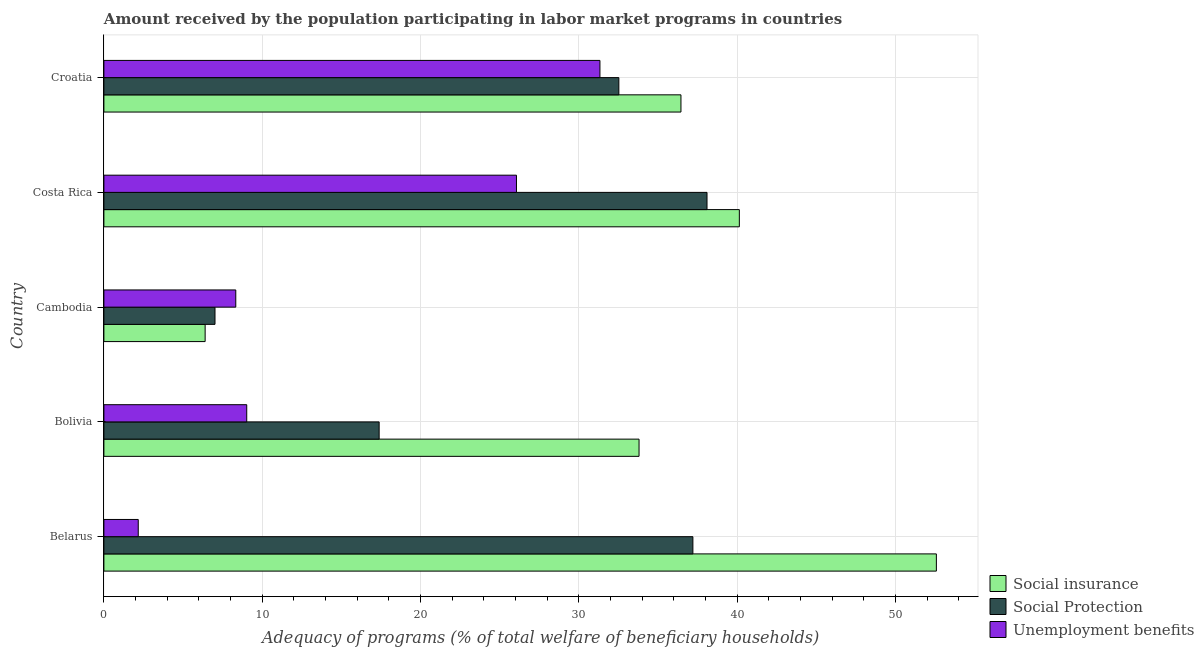How many different coloured bars are there?
Your answer should be very brief. 3. Are the number of bars per tick equal to the number of legend labels?
Offer a very short reply. Yes. What is the label of the 1st group of bars from the top?
Keep it short and to the point. Croatia. What is the amount received by the population participating in social insurance programs in Belarus?
Offer a very short reply. 52.58. Across all countries, what is the maximum amount received by the population participating in social insurance programs?
Your response must be concise. 52.58. Across all countries, what is the minimum amount received by the population participating in social insurance programs?
Your response must be concise. 6.39. In which country was the amount received by the population participating in unemployment benefits programs maximum?
Offer a very short reply. Croatia. In which country was the amount received by the population participating in social insurance programs minimum?
Your answer should be very brief. Cambodia. What is the total amount received by the population participating in social protection programs in the graph?
Offer a very short reply. 132.22. What is the difference between the amount received by the population participating in social protection programs in Belarus and that in Costa Rica?
Offer a very short reply. -0.89. What is the difference between the amount received by the population participating in social insurance programs in Costa Rica and the amount received by the population participating in unemployment benefits programs in Belarus?
Keep it short and to the point. 37.96. What is the average amount received by the population participating in social protection programs per country?
Your answer should be compact. 26.44. What is the difference between the amount received by the population participating in unemployment benefits programs and amount received by the population participating in social insurance programs in Bolivia?
Offer a terse response. -24.78. In how many countries, is the amount received by the population participating in social protection programs greater than 16 %?
Your answer should be compact. 4. What is the ratio of the amount received by the population participating in social protection programs in Belarus to that in Bolivia?
Provide a short and direct response. 2.14. Is the difference between the amount received by the population participating in unemployment benefits programs in Belarus and Costa Rica greater than the difference between the amount received by the population participating in social protection programs in Belarus and Costa Rica?
Your answer should be compact. No. What is the difference between the highest and the second highest amount received by the population participating in unemployment benefits programs?
Offer a very short reply. 5.27. What is the difference between the highest and the lowest amount received by the population participating in social insurance programs?
Give a very brief answer. 46.18. In how many countries, is the amount received by the population participating in social insurance programs greater than the average amount received by the population participating in social insurance programs taken over all countries?
Your answer should be very brief. 3. Is the sum of the amount received by the population participating in social insurance programs in Bolivia and Cambodia greater than the maximum amount received by the population participating in unemployment benefits programs across all countries?
Keep it short and to the point. Yes. What does the 1st bar from the top in Bolivia represents?
Offer a very short reply. Unemployment benefits. What does the 2nd bar from the bottom in Belarus represents?
Offer a terse response. Social Protection. Is it the case that in every country, the sum of the amount received by the population participating in social insurance programs and amount received by the population participating in social protection programs is greater than the amount received by the population participating in unemployment benefits programs?
Offer a very short reply. Yes. How many bars are there?
Give a very brief answer. 15. Are all the bars in the graph horizontal?
Make the answer very short. Yes. How many countries are there in the graph?
Give a very brief answer. 5. What is the difference between two consecutive major ticks on the X-axis?
Your answer should be very brief. 10. Does the graph contain any zero values?
Provide a short and direct response. No. How many legend labels are there?
Provide a succinct answer. 3. How are the legend labels stacked?
Offer a terse response. Vertical. What is the title of the graph?
Your answer should be very brief. Amount received by the population participating in labor market programs in countries. Does "Travel services" appear as one of the legend labels in the graph?
Give a very brief answer. No. What is the label or title of the X-axis?
Your answer should be compact. Adequacy of programs (% of total welfare of beneficiary households). What is the Adequacy of programs (% of total welfare of beneficiary households) in Social insurance in Belarus?
Offer a terse response. 52.58. What is the Adequacy of programs (% of total welfare of beneficiary households) in Social Protection in Belarus?
Provide a short and direct response. 37.2. What is the Adequacy of programs (% of total welfare of beneficiary households) in Unemployment benefits in Belarus?
Give a very brief answer. 2.17. What is the Adequacy of programs (% of total welfare of beneficiary households) of Social insurance in Bolivia?
Offer a very short reply. 33.8. What is the Adequacy of programs (% of total welfare of beneficiary households) in Social Protection in Bolivia?
Offer a terse response. 17.39. What is the Adequacy of programs (% of total welfare of beneficiary households) in Unemployment benefits in Bolivia?
Your response must be concise. 9.02. What is the Adequacy of programs (% of total welfare of beneficiary households) of Social insurance in Cambodia?
Provide a short and direct response. 6.39. What is the Adequacy of programs (% of total welfare of beneficiary households) of Social Protection in Cambodia?
Your response must be concise. 7.02. What is the Adequacy of programs (% of total welfare of beneficiary households) of Unemployment benefits in Cambodia?
Make the answer very short. 8.33. What is the Adequacy of programs (% of total welfare of beneficiary households) in Social insurance in Costa Rica?
Give a very brief answer. 40.13. What is the Adequacy of programs (% of total welfare of beneficiary households) in Social Protection in Costa Rica?
Offer a terse response. 38.09. What is the Adequacy of programs (% of total welfare of beneficiary households) in Unemployment benefits in Costa Rica?
Provide a short and direct response. 26.06. What is the Adequacy of programs (% of total welfare of beneficiary households) of Social insurance in Croatia?
Offer a terse response. 36.45. What is the Adequacy of programs (% of total welfare of beneficiary households) in Social Protection in Croatia?
Ensure brevity in your answer.  32.52. What is the Adequacy of programs (% of total welfare of beneficiary households) of Unemployment benefits in Croatia?
Your answer should be compact. 31.33. Across all countries, what is the maximum Adequacy of programs (% of total welfare of beneficiary households) in Social insurance?
Your response must be concise. 52.58. Across all countries, what is the maximum Adequacy of programs (% of total welfare of beneficiary households) in Social Protection?
Offer a terse response. 38.09. Across all countries, what is the maximum Adequacy of programs (% of total welfare of beneficiary households) in Unemployment benefits?
Keep it short and to the point. 31.33. Across all countries, what is the minimum Adequacy of programs (% of total welfare of beneficiary households) of Social insurance?
Give a very brief answer. 6.39. Across all countries, what is the minimum Adequacy of programs (% of total welfare of beneficiary households) of Social Protection?
Provide a short and direct response. 7.02. Across all countries, what is the minimum Adequacy of programs (% of total welfare of beneficiary households) of Unemployment benefits?
Offer a terse response. 2.17. What is the total Adequacy of programs (% of total welfare of beneficiary households) of Social insurance in the graph?
Provide a succinct answer. 169.36. What is the total Adequacy of programs (% of total welfare of beneficiary households) in Social Protection in the graph?
Your answer should be very brief. 132.22. What is the total Adequacy of programs (% of total welfare of beneficiary households) of Unemployment benefits in the graph?
Provide a short and direct response. 76.91. What is the difference between the Adequacy of programs (% of total welfare of beneficiary households) of Social insurance in Belarus and that in Bolivia?
Your response must be concise. 18.78. What is the difference between the Adequacy of programs (% of total welfare of beneficiary households) of Social Protection in Belarus and that in Bolivia?
Provide a succinct answer. 19.82. What is the difference between the Adequacy of programs (% of total welfare of beneficiary households) of Unemployment benefits in Belarus and that in Bolivia?
Your answer should be very brief. -6.85. What is the difference between the Adequacy of programs (% of total welfare of beneficiary households) of Social insurance in Belarus and that in Cambodia?
Provide a short and direct response. 46.18. What is the difference between the Adequacy of programs (% of total welfare of beneficiary households) of Social Protection in Belarus and that in Cambodia?
Keep it short and to the point. 30.18. What is the difference between the Adequacy of programs (% of total welfare of beneficiary households) of Unemployment benefits in Belarus and that in Cambodia?
Offer a very short reply. -6.16. What is the difference between the Adequacy of programs (% of total welfare of beneficiary households) of Social insurance in Belarus and that in Costa Rica?
Keep it short and to the point. 12.44. What is the difference between the Adequacy of programs (% of total welfare of beneficiary households) in Social Protection in Belarus and that in Costa Rica?
Offer a very short reply. -0.89. What is the difference between the Adequacy of programs (% of total welfare of beneficiary households) of Unemployment benefits in Belarus and that in Costa Rica?
Give a very brief answer. -23.89. What is the difference between the Adequacy of programs (% of total welfare of beneficiary households) in Social insurance in Belarus and that in Croatia?
Provide a short and direct response. 16.13. What is the difference between the Adequacy of programs (% of total welfare of beneficiary households) in Social Protection in Belarus and that in Croatia?
Offer a terse response. 4.68. What is the difference between the Adequacy of programs (% of total welfare of beneficiary households) in Unemployment benefits in Belarus and that in Croatia?
Your answer should be compact. -29.16. What is the difference between the Adequacy of programs (% of total welfare of beneficiary households) of Social insurance in Bolivia and that in Cambodia?
Keep it short and to the point. 27.41. What is the difference between the Adequacy of programs (% of total welfare of beneficiary households) in Social Protection in Bolivia and that in Cambodia?
Provide a succinct answer. 10.37. What is the difference between the Adequacy of programs (% of total welfare of beneficiary households) of Unemployment benefits in Bolivia and that in Cambodia?
Your answer should be compact. 0.69. What is the difference between the Adequacy of programs (% of total welfare of beneficiary households) of Social insurance in Bolivia and that in Costa Rica?
Provide a short and direct response. -6.33. What is the difference between the Adequacy of programs (% of total welfare of beneficiary households) in Social Protection in Bolivia and that in Costa Rica?
Offer a terse response. -20.71. What is the difference between the Adequacy of programs (% of total welfare of beneficiary households) of Unemployment benefits in Bolivia and that in Costa Rica?
Your answer should be very brief. -17.04. What is the difference between the Adequacy of programs (% of total welfare of beneficiary households) of Social insurance in Bolivia and that in Croatia?
Your answer should be compact. -2.65. What is the difference between the Adequacy of programs (% of total welfare of beneficiary households) of Social Protection in Bolivia and that in Croatia?
Ensure brevity in your answer.  -15.14. What is the difference between the Adequacy of programs (% of total welfare of beneficiary households) of Unemployment benefits in Bolivia and that in Croatia?
Offer a terse response. -22.31. What is the difference between the Adequacy of programs (% of total welfare of beneficiary households) of Social insurance in Cambodia and that in Costa Rica?
Offer a terse response. -33.74. What is the difference between the Adequacy of programs (% of total welfare of beneficiary households) in Social Protection in Cambodia and that in Costa Rica?
Ensure brevity in your answer.  -31.08. What is the difference between the Adequacy of programs (% of total welfare of beneficiary households) of Unemployment benefits in Cambodia and that in Costa Rica?
Give a very brief answer. -17.73. What is the difference between the Adequacy of programs (% of total welfare of beneficiary households) of Social insurance in Cambodia and that in Croatia?
Provide a succinct answer. -30.05. What is the difference between the Adequacy of programs (% of total welfare of beneficiary households) of Social Protection in Cambodia and that in Croatia?
Offer a terse response. -25.51. What is the difference between the Adequacy of programs (% of total welfare of beneficiary households) in Unemployment benefits in Cambodia and that in Croatia?
Give a very brief answer. -23. What is the difference between the Adequacy of programs (% of total welfare of beneficiary households) in Social insurance in Costa Rica and that in Croatia?
Give a very brief answer. 3.69. What is the difference between the Adequacy of programs (% of total welfare of beneficiary households) in Social Protection in Costa Rica and that in Croatia?
Your response must be concise. 5.57. What is the difference between the Adequacy of programs (% of total welfare of beneficiary households) of Unemployment benefits in Costa Rica and that in Croatia?
Make the answer very short. -5.27. What is the difference between the Adequacy of programs (% of total welfare of beneficiary households) in Social insurance in Belarus and the Adequacy of programs (% of total welfare of beneficiary households) in Social Protection in Bolivia?
Ensure brevity in your answer.  35.19. What is the difference between the Adequacy of programs (% of total welfare of beneficiary households) of Social insurance in Belarus and the Adequacy of programs (% of total welfare of beneficiary households) of Unemployment benefits in Bolivia?
Your answer should be very brief. 43.56. What is the difference between the Adequacy of programs (% of total welfare of beneficiary households) of Social Protection in Belarus and the Adequacy of programs (% of total welfare of beneficiary households) of Unemployment benefits in Bolivia?
Give a very brief answer. 28.18. What is the difference between the Adequacy of programs (% of total welfare of beneficiary households) of Social insurance in Belarus and the Adequacy of programs (% of total welfare of beneficiary households) of Social Protection in Cambodia?
Ensure brevity in your answer.  45.56. What is the difference between the Adequacy of programs (% of total welfare of beneficiary households) of Social insurance in Belarus and the Adequacy of programs (% of total welfare of beneficiary households) of Unemployment benefits in Cambodia?
Provide a short and direct response. 44.25. What is the difference between the Adequacy of programs (% of total welfare of beneficiary households) in Social Protection in Belarus and the Adequacy of programs (% of total welfare of beneficiary households) in Unemployment benefits in Cambodia?
Your response must be concise. 28.87. What is the difference between the Adequacy of programs (% of total welfare of beneficiary households) of Social insurance in Belarus and the Adequacy of programs (% of total welfare of beneficiary households) of Social Protection in Costa Rica?
Make the answer very short. 14.49. What is the difference between the Adequacy of programs (% of total welfare of beneficiary households) of Social insurance in Belarus and the Adequacy of programs (% of total welfare of beneficiary households) of Unemployment benefits in Costa Rica?
Your answer should be very brief. 26.52. What is the difference between the Adequacy of programs (% of total welfare of beneficiary households) of Social Protection in Belarus and the Adequacy of programs (% of total welfare of beneficiary households) of Unemployment benefits in Costa Rica?
Give a very brief answer. 11.14. What is the difference between the Adequacy of programs (% of total welfare of beneficiary households) in Social insurance in Belarus and the Adequacy of programs (% of total welfare of beneficiary households) in Social Protection in Croatia?
Give a very brief answer. 20.05. What is the difference between the Adequacy of programs (% of total welfare of beneficiary households) in Social insurance in Belarus and the Adequacy of programs (% of total welfare of beneficiary households) in Unemployment benefits in Croatia?
Make the answer very short. 21.25. What is the difference between the Adequacy of programs (% of total welfare of beneficiary households) of Social Protection in Belarus and the Adequacy of programs (% of total welfare of beneficiary households) of Unemployment benefits in Croatia?
Offer a very short reply. 5.87. What is the difference between the Adequacy of programs (% of total welfare of beneficiary households) in Social insurance in Bolivia and the Adequacy of programs (% of total welfare of beneficiary households) in Social Protection in Cambodia?
Your answer should be compact. 26.78. What is the difference between the Adequacy of programs (% of total welfare of beneficiary households) in Social insurance in Bolivia and the Adequacy of programs (% of total welfare of beneficiary households) in Unemployment benefits in Cambodia?
Your answer should be very brief. 25.47. What is the difference between the Adequacy of programs (% of total welfare of beneficiary households) of Social Protection in Bolivia and the Adequacy of programs (% of total welfare of beneficiary households) of Unemployment benefits in Cambodia?
Provide a succinct answer. 9.05. What is the difference between the Adequacy of programs (% of total welfare of beneficiary households) in Social insurance in Bolivia and the Adequacy of programs (% of total welfare of beneficiary households) in Social Protection in Costa Rica?
Keep it short and to the point. -4.29. What is the difference between the Adequacy of programs (% of total welfare of beneficiary households) of Social insurance in Bolivia and the Adequacy of programs (% of total welfare of beneficiary households) of Unemployment benefits in Costa Rica?
Your answer should be compact. 7.74. What is the difference between the Adequacy of programs (% of total welfare of beneficiary households) of Social Protection in Bolivia and the Adequacy of programs (% of total welfare of beneficiary households) of Unemployment benefits in Costa Rica?
Provide a short and direct response. -8.67. What is the difference between the Adequacy of programs (% of total welfare of beneficiary households) of Social insurance in Bolivia and the Adequacy of programs (% of total welfare of beneficiary households) of Social Protection in Croatia?
Provide a succinct answer. 1.28. What is the difference between the Adequacy of programs (% of total welfare of beneficiary households) in Social insurance in Bolivia and the Adequacy of programs (% of total welfare of beneficiary households) in Unemployment benefits in Croatia?
Provide a succinct answer. 2.47. What is the difference between the Adequacy of programs (% of total welfare of beneficiary households) of Social Protection in Bolivia and the Adequacy of programs (% of total welfare of beneficiary households) of Unemployment benefits in Croatia?
Your response must be concise. -13.95. What is the difference between the Adequacy of programs (% of total welfare of beneficiary households) in Social insurance in Cambodia and the Adequacy of programs (% of total welfare of beneficiary households) in Social Protection in Costa Rica?
Give a very brief answer. -31.7. What is the difference between the Adequacy of programs (% of total welfare of beneficiary households) of Social insurance in Cambodia and the Adequacy of programs (% of total welfare of beneficiary households) of Unemployment benefits in Costa Rica?
Provide a short and direct response. -19.66. What is the difference between the Adequacy of programs (% of total welfare of beneficiary households) in Social Protection in Cambodia and the Adequacy of programs (% of total welfare of beneficiary households) in Unemployment benefits in Costa Rica?
Make the answer very short. -19.04. What is the difference between the Adequacy of programs (% of total welfare of beneficiary households) of Social insurance in Cambodia and the Adequacy of programs (% of total welfare of beneficiary households) of Social Protection in Croatia?
Offer a terse response. -26.13. What is the difference between the Adequacy of programs (% of total welfare of beneficiary households) of Social insurance in Cambodia and the Adequacy of programs (% of total welfare of beneficiary households) of Unemployment benefits in Croatia?
Your answer should be very brief. -24.94. What is the difference between the Adequacy of programs (% of total welfare of beneficiary households) in Social Protection in Cambodia and the Adequacy of programs (% of total welfare of beneficiary households) in Unemployment benefits in Croatia?
Offer a very short reply. -24.31. What is the difference between the Adequacy of programs (% of total welfare of beneficiary households) of Social insurance in Costa Rica and the Adequacy of programs (% of total welfare of beneficiary households) of Social Protection in Croatia?
Your answer should be very brief. 7.61. What is the difference between the Adequacy of programs (% of total welfare of beneficiary households) of Social insurance in Costa Rica and the Adequacy of programs (% of total welfare of beneficiary households) of Unemployment benefits in Croatia?
Offer a very short reply. 8.8. What is the difference between the Adequacy of programs (% of total welfare of beneficiary households) in Social Protection in Costa Rica and the Adequacy of programs (% of total welfare of beneficiary households) in Unemployment benefits in Croatia?
Offer a very short reply. 6.76. What is the average Adequacy of programs (% of total welfare of beneficiary households) of Social insurance per country?
Ensure brevity in your answer.  33.87. What is the average Adequacy of programs (% of total welfare of beneficiary households) of Social Protection per country?
Offer a very short reply. 26.44. What is the average Adequacy of programs (% of total welfare of beneficiary households) of Unemployment benefits per country?
Provide a succinct answer. 15.38. What is the difference between the Adequacy of programs (% of total welfare of beneficiary households) of Social insurance and Adequacy of programs (% of total welfare of beneficiary households) of Social Protection in Belarus?
Provide a short and direct response. 15.38. What is the difference between the Adequacy of programs (% of total welfare of beneficiary households) of Social insurance and Adequacy of programs (% of total welfare of beneficiary households) of Unemployment benefits in Belarus?
Offer a terse response. 50.41. What is the difference between the Adequacy of programs (% of total welfare of beneficiary households) in Social Protection and Adequacy of programs (% of total welfare of beneficiary households) in Unemployment benefits in Belarus?
Ensure brevity in your answer.  35.03. What is the difference between the Adequacy of programs (% of total welfare of beneficiary households) of Social insurance and Adequacy of programs (% of total welfare of beneficiary households) of Social Protection in Bolivia?
Provide a succinct answer. 16.41. What is the difference between the Adequacy of programs (% of total welfare of beneficiary households) in Social insurance and Adequacy of programs (% of total welfare of beneficiary households) in Unemployment benefits in Bolivia?
Make the answer very short. 24.78. What is the difference between the Adequacy of programs (% of total welfare of beneficiary households) in Social Protection and Adequacy of programs (% of total welfare of beneficiary households) in Unemployment benefits in Bolivia?
Your response must be concise. 8.36. What is the difference between the Adequacy of programs (% of total welfare of beneficiary households) of Social insurance and Adequacy of programs (% of total welfare of beneficiary households) of Social Protection in Cambodia?
Ensure brevity in your answer.  -0.62. What is the difference between the Adequacy of programs (% of total welfare of beneficiary households) of Social insurance and Adequacy of programs (% of total welfare of beneficiary households) of Unemployment benefits in Cambodia?
Offer a terse response. -1.94. What is the difference between the Adequacy of programs (% of total welfare of beneficiary households) of Social Protection and Adequacy of programs (% of total welfare of beneficiary households) of Unemployment benefits in Cambodia?
Give a very brief answer. -1.31. What is the difference between the Adequacy of programs (% of total welfare of beneficiary households) in Social insurance and Adequacy of programs (% of total welfare of beneficiary households) in Social Protection in Costa Rica?
Make the answer very short. 2.04. What is the difference between the Adequacy of programs (% of total welfare of beneficiary households) of Social insurance and Adequacy of programs (% of total welfare of beneficiary households) of Unemployment benefits in Costa Rica?
Make the answer very short. 14.08. What is the difference between the Adequacy of programs (% of total welfare of beneficiary households) of Social Protection and Adequacy of programs (% of total welfare of beneficiary households) of Unemployment benefits in Costa Rica?
Offer a very short reply. 12.04. What is the difference between the Adequacy of programs (% of total welfare of beneficiary households) of Social insurance and Adequacy of programs (% of total welfare of beneficiary households) of Social Protection in Croatia?
Provide a short and direct response. 3.92. What is the difference between the Adequacy of programs (% of total welfare of beneficiary households) in Social insurance and Adequacy of programs (% of total welfare of beneficiary households) in Unemployment benefits in Croatia?
Ensure brevity in your answer.  5.12. What is the difference between the Adequacy of programs (% of total welfare of beneficiary households) of Social Protection and Adequacy of programs (% of total welfare of beneficiary households) of Unemployment benefits in Croatia?
Offer a very short reply. 1.19. What is the ratio of the Adequacy of programs (% of total welfare of beneficiary households) of Social insurance in Belarus to that in Bolivia?
Your answer should be compact. 1.56. What is the ratio of the Adequacy of programs (% of total welfare of beneficiary households) in Social Protection in Belarus to that in Bolivia?
Keep it short and to the point. 2.14. What is the ratio of the Adequacy of programs (% of total welfare of beneficiary households) in Unemployment benefits in Belarus to that in Bolivia?
Offer a very short reply. 0.24. What is the ratio of the Adequacy of programs (% of total welfare of beneficiary households) in Social insurance in Belarus to that in Cambodia?
Give a very brief answer. 8.22. What is the ratio of the Adequacy of programs (% of total welfare of beneficiary households) of Social Protection in Belarus to that in Cambodia?
Provide a short and direct response. 5.3. What is the ratio of the Adequacy of programs (% of total welfare of beneficiary households) of Unemployment benefits in Belarus to that in Cambodia?
Your answer should be very brief. 0.26. What is the ratio of the Adequacy of programs (% of total welfare of beneficiary households) of Social insurance in Belarus to that in Costa Rica?
Provide a short and direct response. 1.31. What is the ratio of the Adequacy of programs (% of total welfare of beneficiary households) of Social Protection in Belarus to that in Costa Rica?
Offer a terse response. 0.98. What is the ratio of the Adequacy of programs (% of total welfare of beneficiary households) in Unemployment benefits in Belarus to that in Costa Rica?
Make the answer very short. 0.08. What is the ratio of the Adequacy of programs (% of total welfare of beneficiary households) of Social insurance in Belarus to that in Croatia?
Your response must be concise. 1.44. What is the ratio of the Adequacy of programs (% of total welfare of beneficiary households) of Social Protection in Belarus to that in Croatia?
Offer a terse response. 1.14. What is the ratio of the Adequacy of programs (% of total welfare of beneficiary households) in Unemployment benefits in Belarus to that in Croatia?
Provide a succinct answer. 0.07. What is the ratio of the Adequacy of programs (% of total welfare of beneficiary households) of Social insurance in Bolivia to that in Cambodia?
Provide a short and direct response. 5.29. What is the ratio of the Adequacy of programs (% of total welfare of beneficiary households) in Social Protection in Bolivia to that in Cambodia?
Your answer should be very brief. 2.48. What is the ratio of the Adequacy of programs (% of total welfare of beneficiary households) in Unemployment benefits in Bolivia to that in Cambodia?
Your answer should be very brief. 1.08. What is the ratio of the Adequacy of programs (% of total welfare of beneficiary households) in Social insurance in Bolivia to that in Costa Rica?
Offer a terse response. 0.84. What is the ratio of the Adequacy of programs (% of total welfare of beneficiary households) of Social Protection in Bolivia to that in Costa Rica?
Your answer should be very brief. 0.46. What is the ratio of the Adequacy of programs (% of total welfare of beneficiary households) in Unemployment benefits in Bolivia to that in Costa Rica?
Your response must be concise. 0.35. What is the ratio of the Adequacy of programs (% of total welfare of beneficiary households) in Social insurance in Bolivia to that in Croatia?
Your answer should be compact. 0.93. What is the ratio of the Adequacy of programs (% of total welfare of beneficiary households) in Social Protection in Bolivia to that in Croatia?
Your answer should be compact. 0.53. What is the ratio of the Adequacy of programs (% of total welfare of beneficiary households) of Unemployment benefits in Bolivia to that in Croatia?
Your response must be concise. 0.29. What is the ratio of the Adequacy of programs (% of total welfare of beneficiary households) of Social insurance in Cambodia to that in Costa Rica?
Keep it short and to the point. 0.16. What is the ratio of the Adequacy of programs (% of total welfare of beneficiary households) in Social Protection in Cambodia to that in Costa Rica?
Provide a succinct answer. 0.18. What is the ratio of the Adequacy of programs (% of total welfare of beneficiary households) of Unemployment benefits in Cambodia to that in Costa Rica?
Your response must be concise. 0.32. What is the ratio of the Adequacy of programs (% of total welfare of beneficiary households) in Social insurance in Cambodia to that in Croatia?
Provide a succinct answer. 0.18. What is the ratio of the Adequacy of programs (% of total welfare of beneficiary households) of Social Protection in Cambodia to that in Croatia?
Offer a very short reply. 0.22. What is the ratio of the Adequacy of programs (% of total welfare of beneficiary households) of Unemployment benefits in Cambodia to that in Croatia?
Give a very brief answer. 0.27. What is the ratio of the Adequacy of programs (% of total welfare of beneficiary households) of Social insurance in Costa Rica to that in Croatia?
Ensure brevity in your answer.  1.1. What is the ratio of the Adequacy of programs (% of total welfare of beneficiary households) in Social Protection in Costa Rica to that in Croatia?
Offer a very short reply. 1.17. What is the ratio of the Adequacy of programs (% of total welfare of beneficiary households) in Unemployment benefits in Costa Rica to that in Croatia?
Your response must be concise. 0.83. What is the difference between the highest and the second highest Adequacy of programs (% of total welfare of beneficiary households) in Social insurance?
Offer a very short reply. 12.44. What is the difference between the highest and the second highest Adequacy of programs (% of total welfare of beneficiary households) of Social Protection?
Ensure brevity in your answer.  0.89. What is the difference between the highest and the second highest Adequacy of programs (% of total welfare of beneficiary households) in Unemployment benefits?
Make the answer very short. 5.27. What is the difference between the highest and the lowest Adequacy of programs (% of total welfare of beneficiary households) of Social insurance?
Your answer should be compact. 46.18. What is the difference between the highest and the lowest Adequacy of programs (% of total welfare of beneficiary households) in Social Protection?
Provide a succinct answer. 31.08. What is the difference between the highest and the lowest Adequacy of programs (% of total welfare of beneficiary households) of Unemployment benefits?
Give a very brief answer. 29.16. 